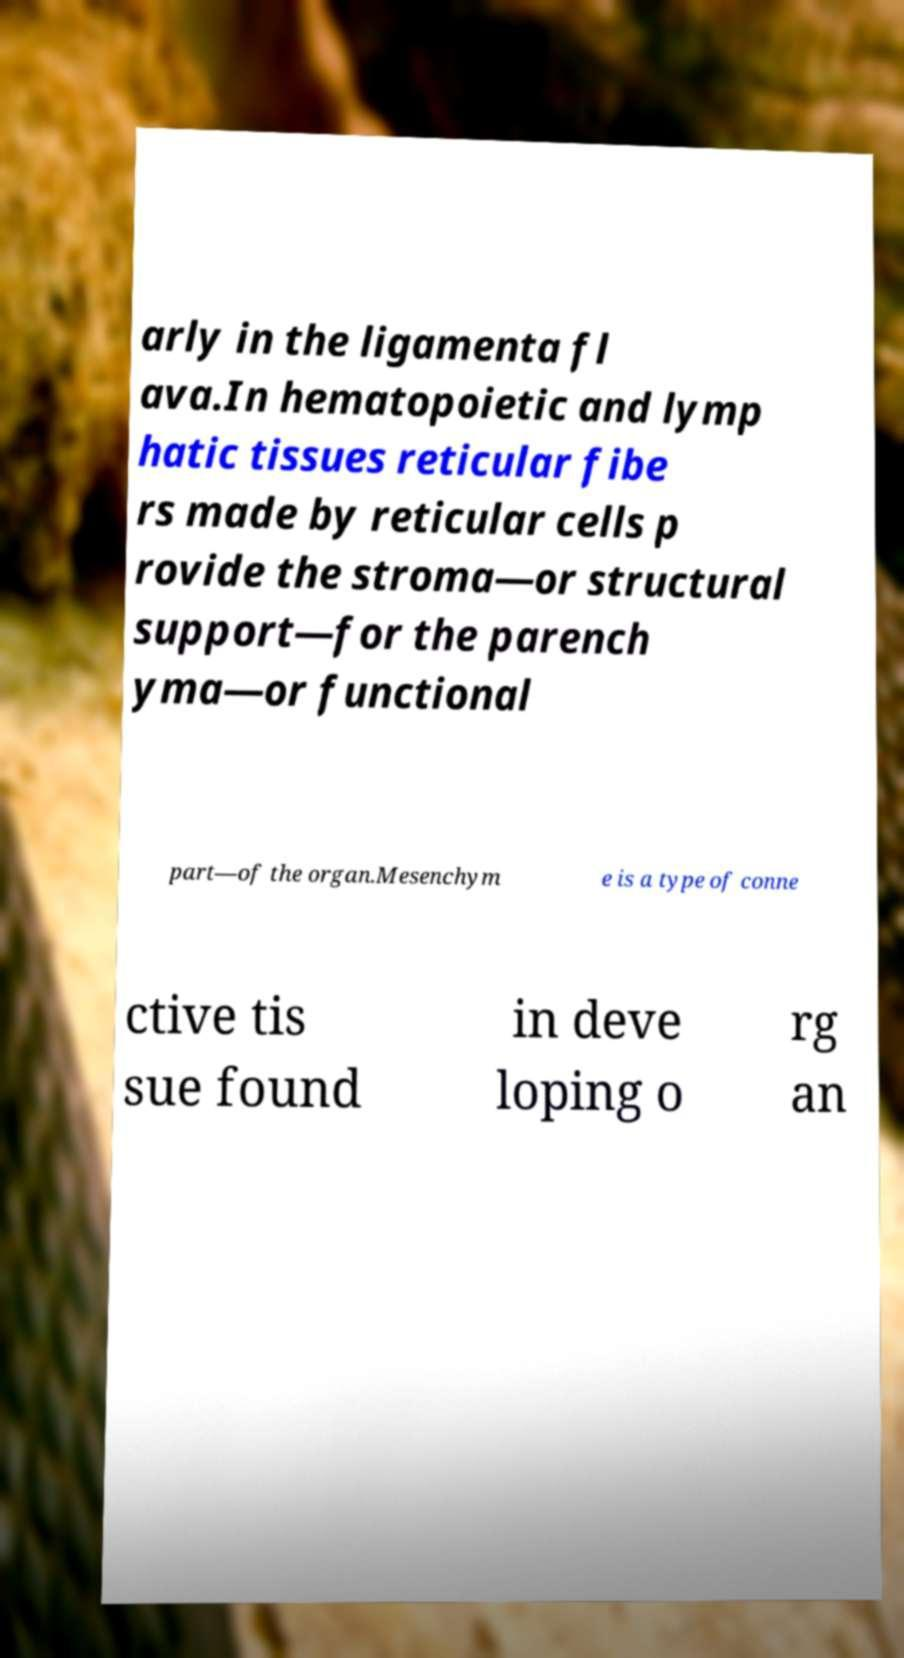What messages or text are displayed in this image? I need them in a readable, typed format. arly in the ligamenta fl ava.In hematopoietic and lymp hatic tissues reticular fibe rs made by reticular cells p rovide the stroma—or structural support—for the parench yma—or functional part—of the organ.Mesenchym e is a type of conne ctive tis sue found in deve loping o rg an 